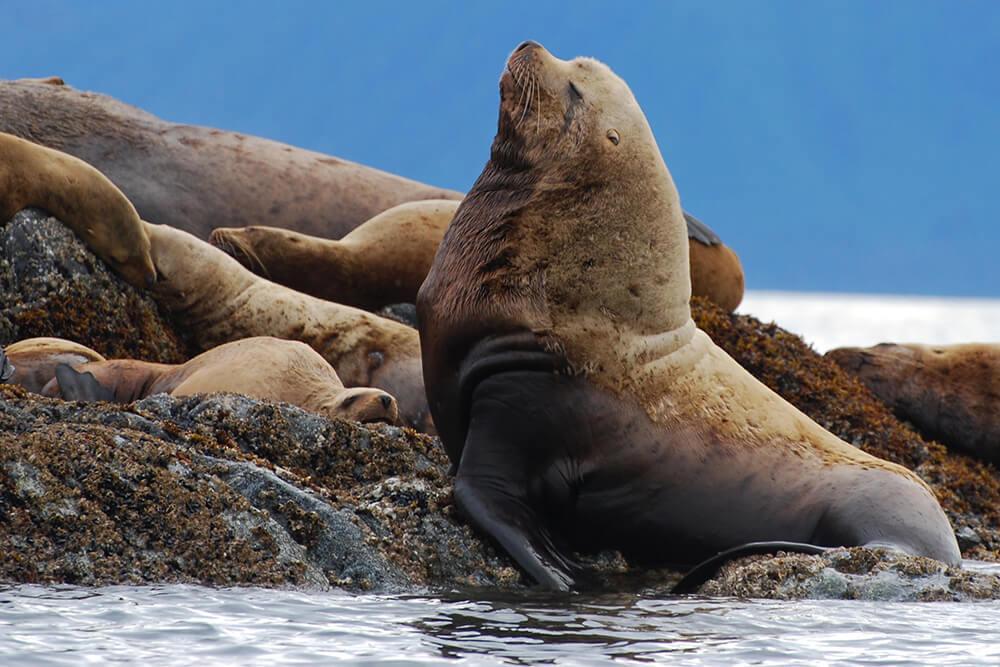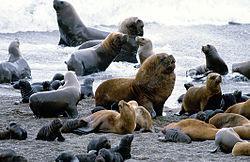The first image is the image on the left, the second image is the image on the right. Given the left and right images, does the statement "One image shows exactly two seals, which are of different sizes." hold true? Answer yes or no. No. The first image is the image on the left, the second image is the image on the right. For the images shown, is this caption "One of the images shows exactly two sea lions." true? Answer yes or no. No. The first image is the image on the left, the second image is the image on the right. Examine the images to the left and right. Is the description "There is 1 male seal next to 1 female." accurate? Answer yes or no. No. 